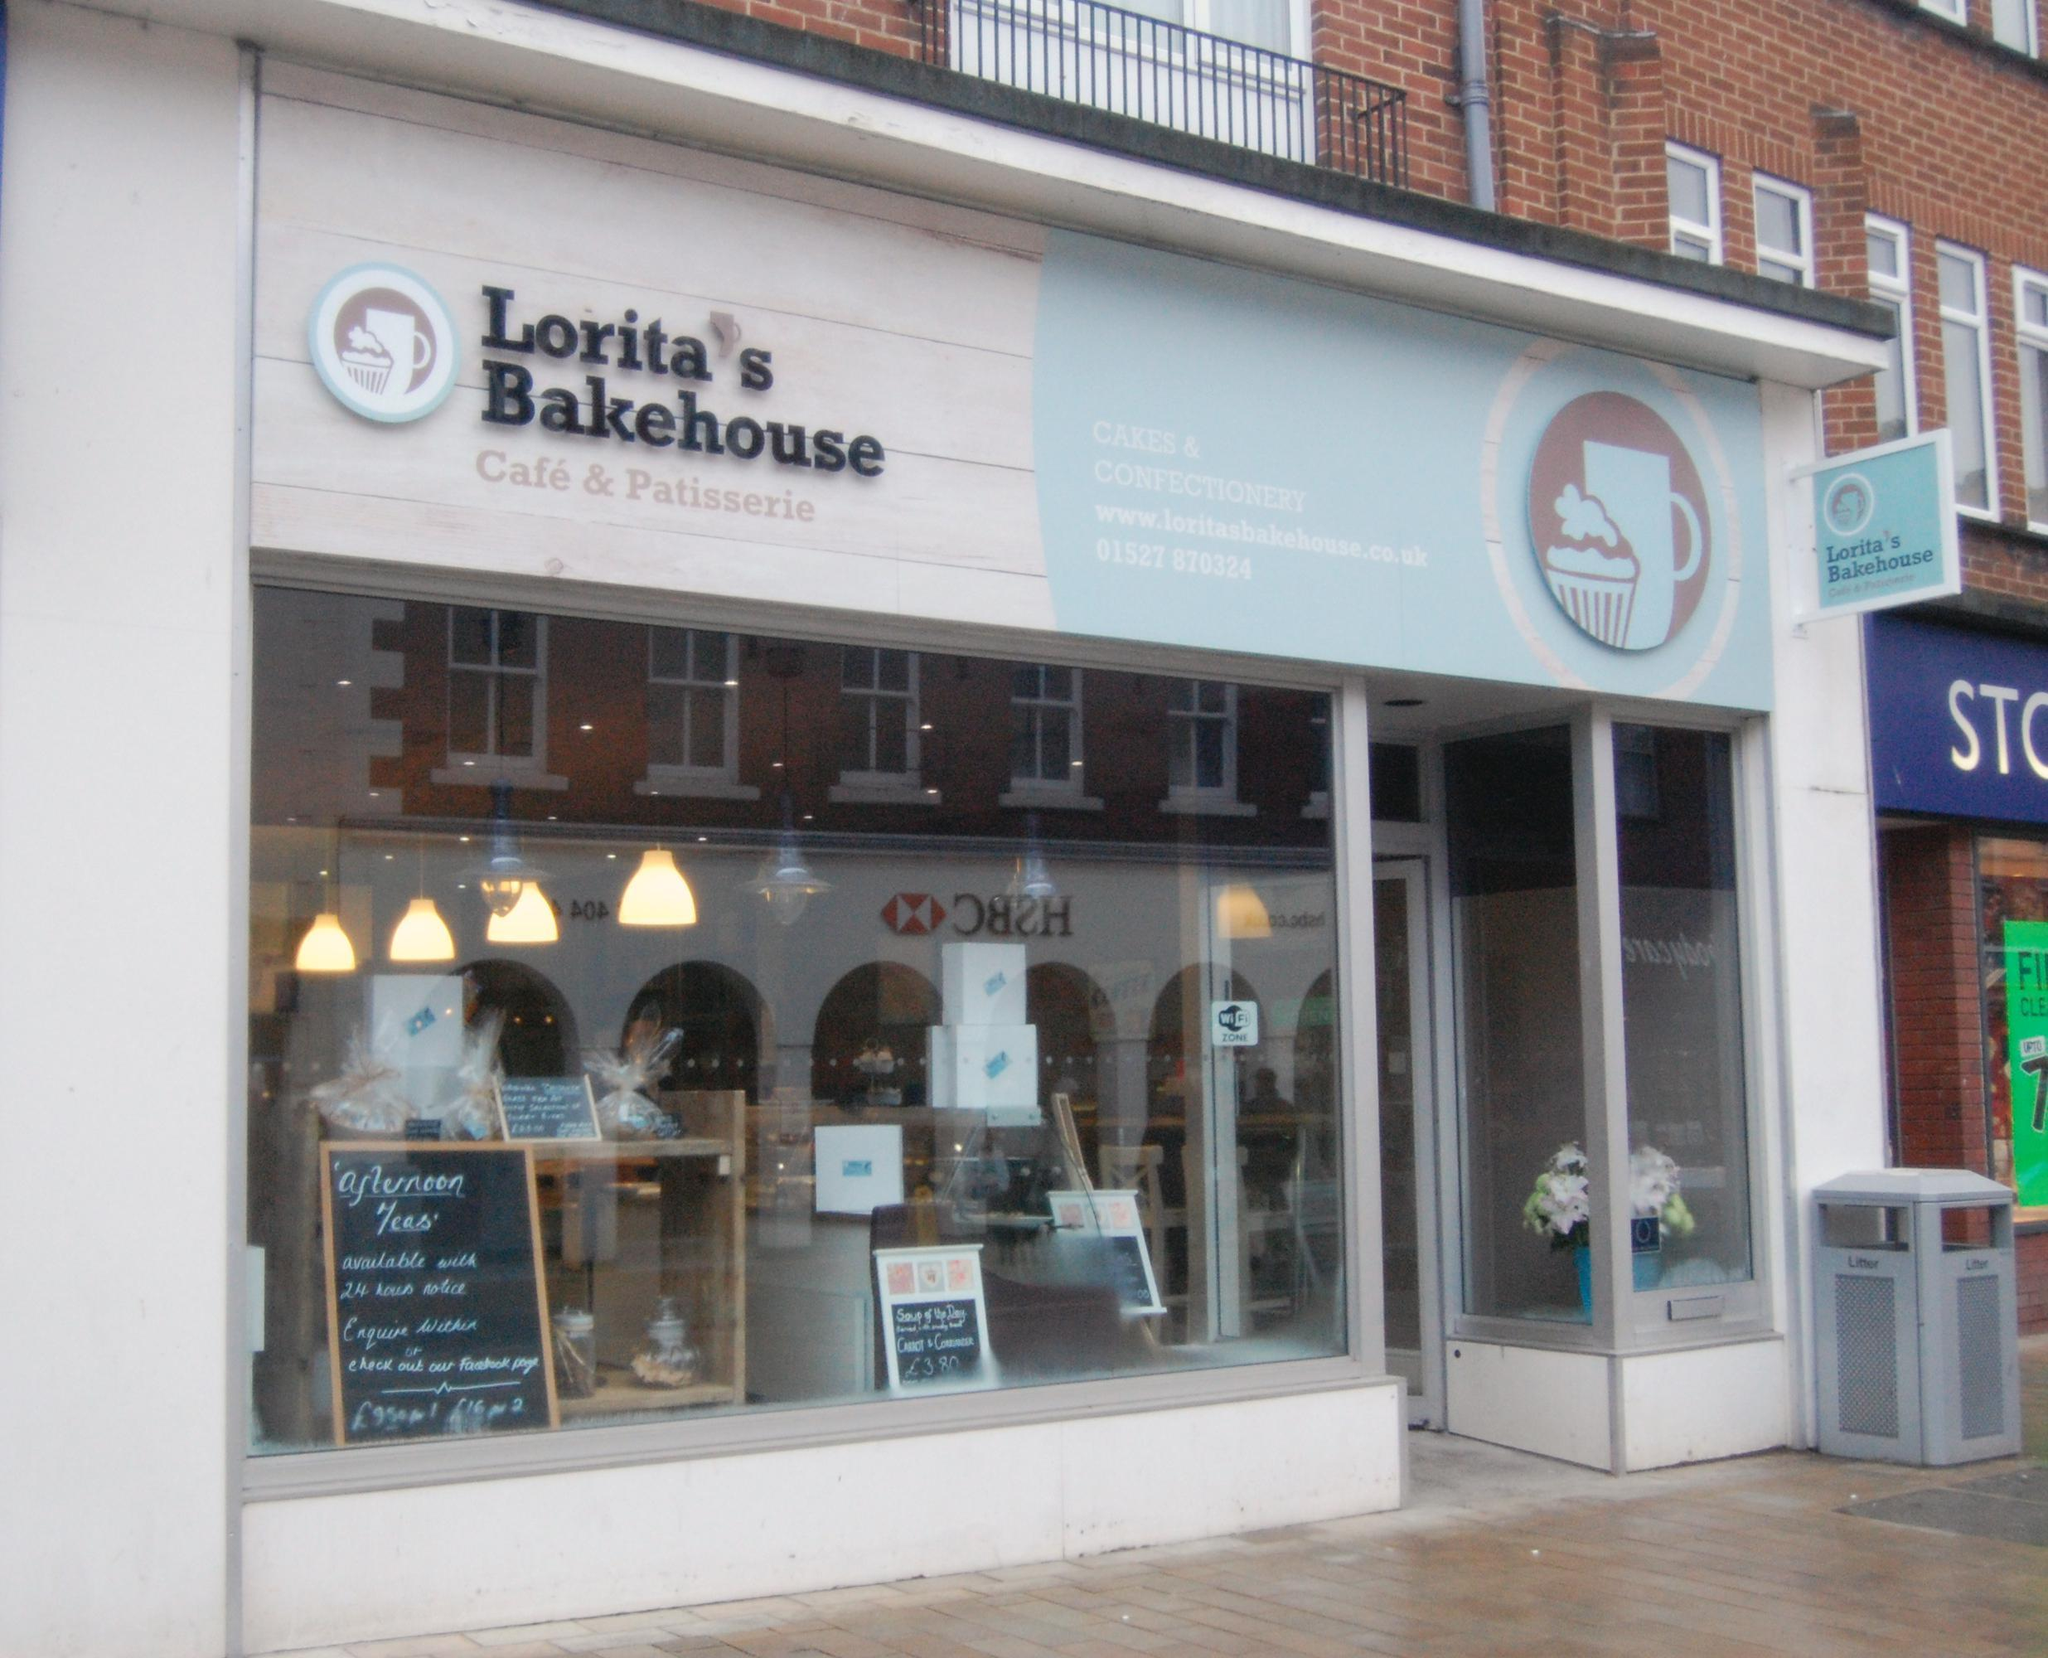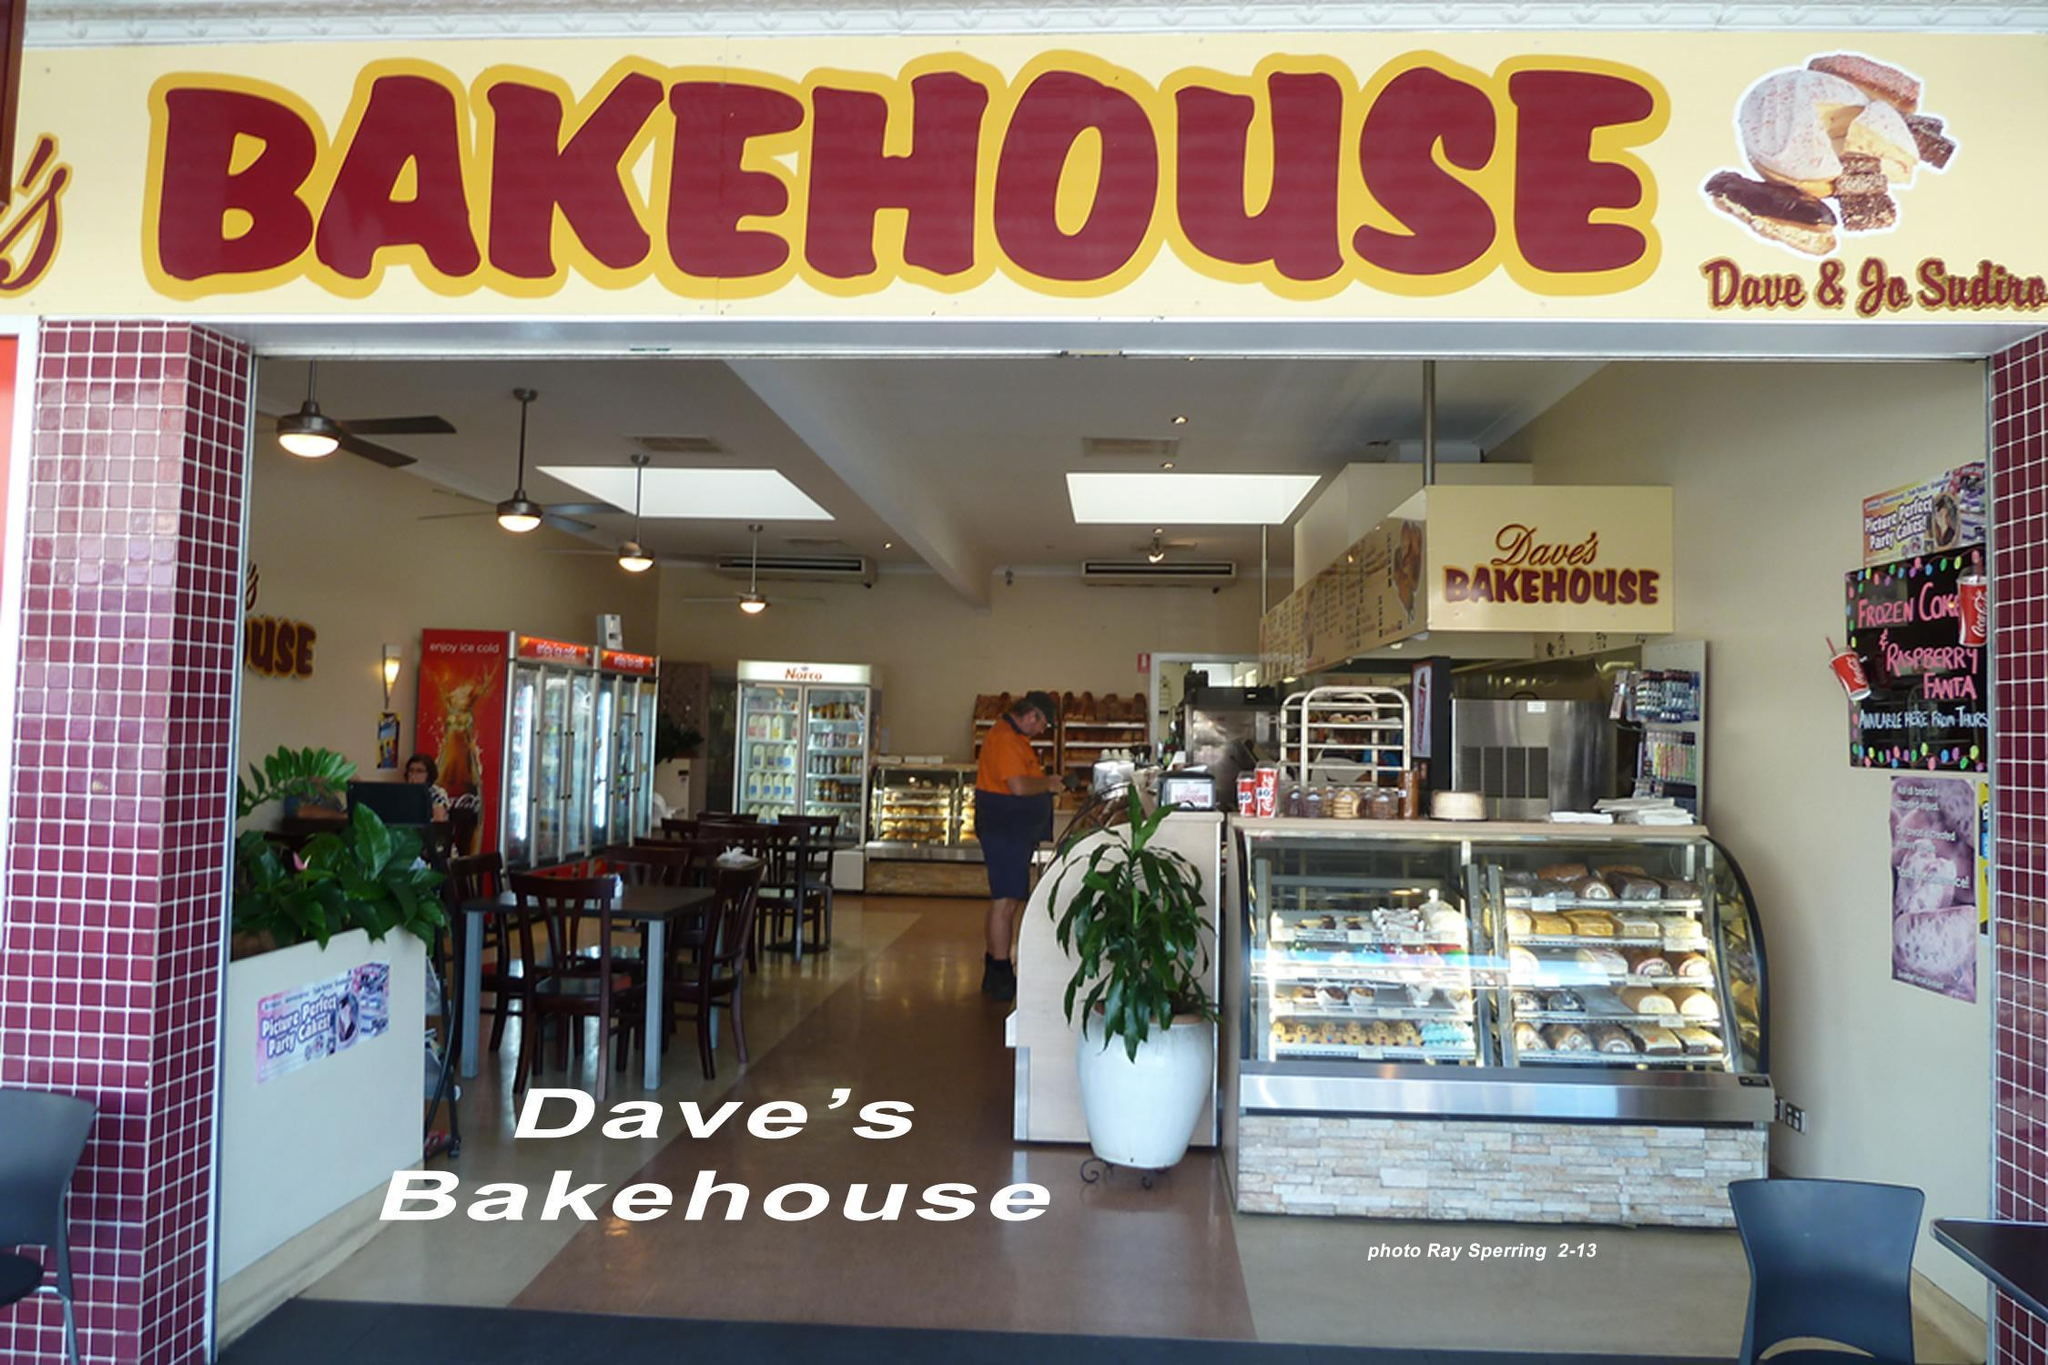The first image is the image on the left, the second image is the image on the right. For the images displayed, is the sentence "Traingular pennants are on display in the image on the right." factually correct? Answer yes or no. No. 